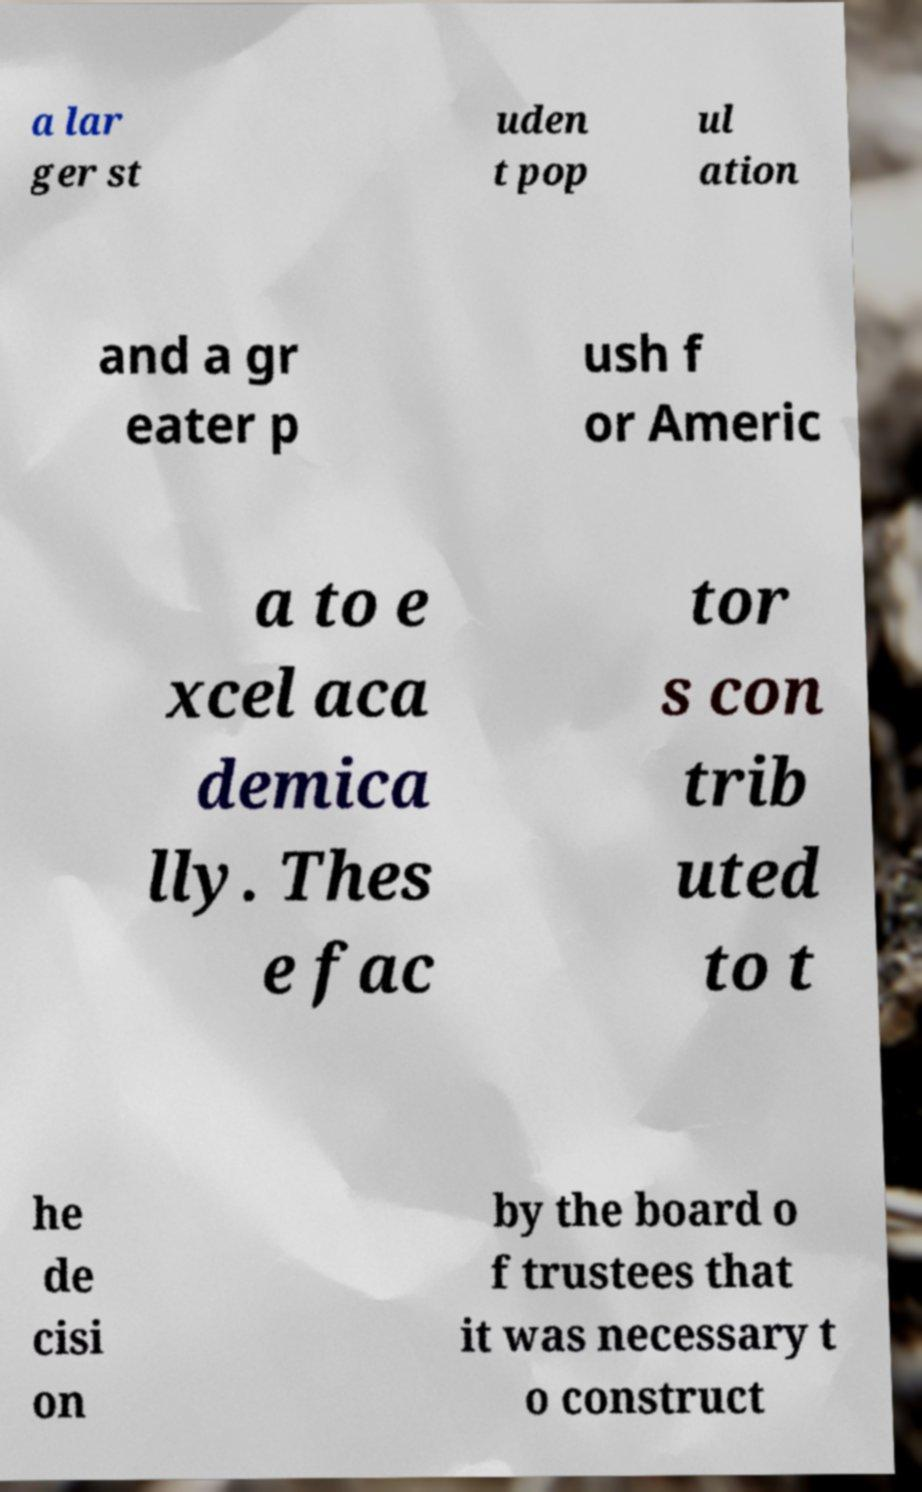There's text embedded in this image that I need extracted. Can you transcribe it verbatim? a lar ger st uden t pop ul ation and a gr eater p ush f or Americ a to e xcel aca demica lly. Thes e fac tor s con trib uted to t he de cisi on by the board o f trustees that it was necessary t o construct 